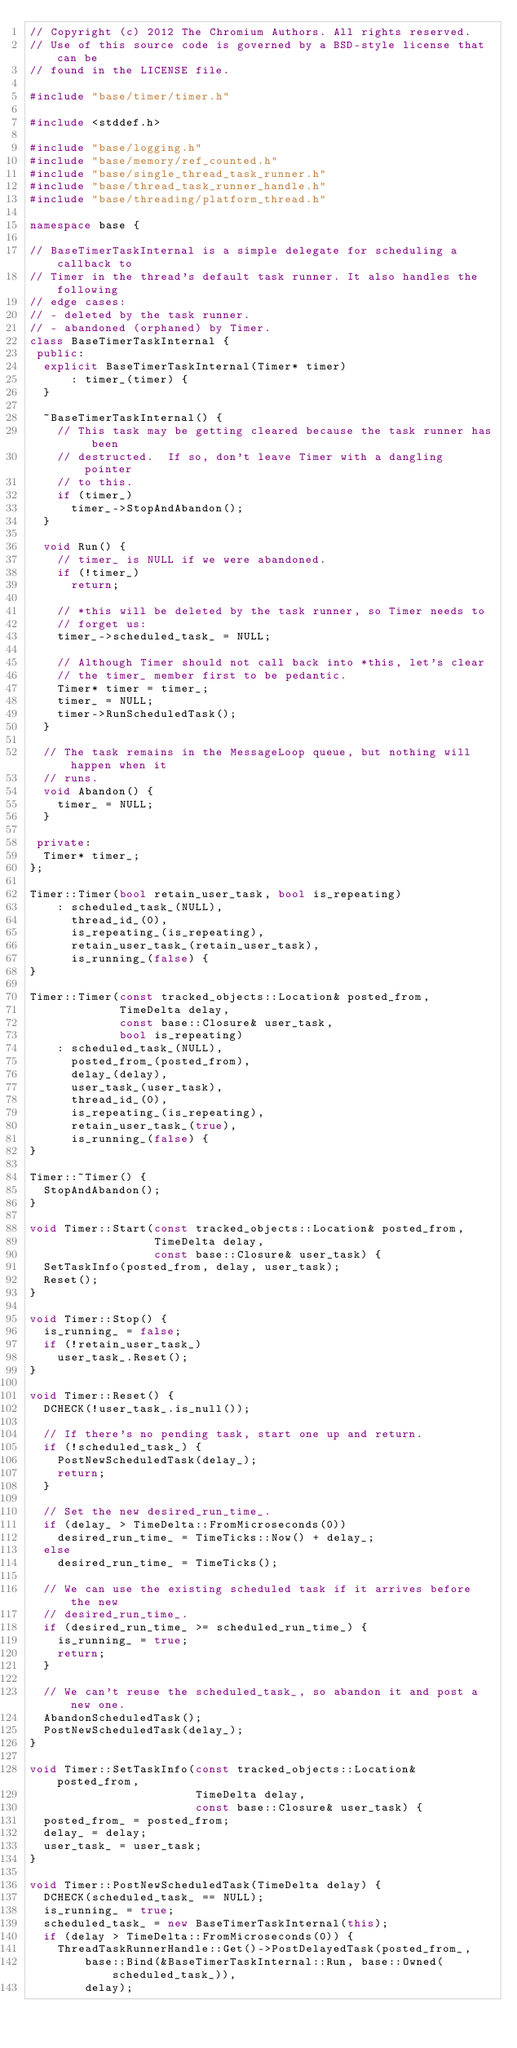<code> <loc_0><loc_0><loc_500><loc_500><_C++_>// Copyright (c) 2012 The Chromium Authors. All rights reserved.
// Use of this source code is governed by a BSD-style license that can be
// found in the LICENSE file.

#include "base/timer/timer.h"

#include <stddef.h>

#include "base/logging.h"
#include "base/memory/ref_counted.h"
#include "base/single_thread_task_runner.h"
#include "base/thread_task_runner_handle.h"
#include "base/threading/platform_thread.h"

namespace base {

// BaseTimerTaskInternal is a simple delegate for scheduling a callback to
// Timer in the thread's default task runner. It also handles the following
// edge cases:
// - deleted by the task runner.
// - abandoned (orphaned) by Timer.
class BaseTimerTaskInternal {
 public:
  explicit BaseTimerTaskInternal(Timer* timer)
      : timer_(timer) {
  }

  ~BaseTimerTaskInternal() {
    // This task may be getting cleared because the task runner has been
    // destructed.  If so, don't leave Timer with a dangling pointer
    // to this.
    if (timer_)
      timer_->StopAndAbandon();
  }

  void Run() {
    // timer_ is NULL if we were abandoned.
    if (!timer_)
      return;

    // *this will be deleted by the task runner, so Timer needs to
    // forget us:
    timer_->scheduled_task_ = NULL;

    // Although Timer should not call back into *this, let's clear
    // the timer_ member first to be pedantic.
    Timer* timer = timer_;
    timer_ = NULL;
    timer->RunScheduledTask();
  }

  // The task remains in the MessageLoop queue, but nothing will happen when it
  // runs.
  void Abandon() {
    timer_ = NULL;
  }

 private:
  Timer* timer_;
};

Timer::Timer(bool retain_user_task, bool is_repeating)
    : scheduled_task_(NULL),
      thread_id_(0),
      is_repeating_(is_repeating),
      retain_user_task_(retain_user_task),
      is_running_(false) {
}

Timer::Timer(const tracked_objects::Location& posted_from,
             TimeDelta delay,
             const base::Closure& user_task,
             bool is_repeating)
    : scheduled_task_(NULL),
      posted_from_(posted_from),
      delay_(delay),
      user_task_(user_task),
      thread_id_(0),
      is_repeating_(is_repeating),
      retain_user_task_(true),
      is_running_(false) {
}

Timer::~Timer() {
  StopAndAbandon();
}

void Timer::Start(const tracked_objects::Location& posted_from,
                  TimeDelta delay,
                  const base::Closure& user_task) {
  SetTaskInfo(posted_from, delay, user_task);
  Reset();
}

void Timer::Stop() {
  is_running_ = false;
  if (!retain_user_task_)
    user_task_.Reset();
}

void Timer::Reset() {
  DCHECK(!user_task_.is_null());

  // If there's no pending task, start one up and return.
  if (!scheduled_task_) {
    PostNewScheduledTask(delay_);
    return;
  }

  // Set the new desired_run_time_.
  if (delay_ > TimeDelta::FromMicroseconds(0))
    desired_run_time_ = TimeTicks::Now() + delay_;
  else
    desired_run_time_ = TimeTicks();

  // We can use the existing scheduled task if it arrives before the new
  // desired_run_time_.
  if (desired_run_time_ >= scheduled_run_time_) {
    is_running_ = true;
    return;
  }

  // We can't reuse the scheduled_task_, so abandon it and post a new one.
  AbandonScheduledTask();
  PostNewScheduledTask(delay_);
}

void Timer::SetTaskInfo(const tracked_objects::Location& posted_from,
                        TimeDelta delay,
                        const base::Closure& user_task) {
  posted_from_ = posted_from;
  delay_ = delay;
  user_task_ = user_task;
}

void Timer::PostNewScheduledTask(TimeDelta delay) {
  DCHECK(scheduled_task_ == NULL);
  is_running_ = true;
  scheduled_task_ = new BaseTimerTaskInternal(this);
  if (delay > TimeDelta::FromMicroseconds(0)) {
    ThreadTaskRunnerHandle::Get()->PostDelayedTask(posted_from_,
        base::Bind(&BaseTimerTaskInternal::Run, base::Owned(scheduled_task_)),
        delay);</code> 